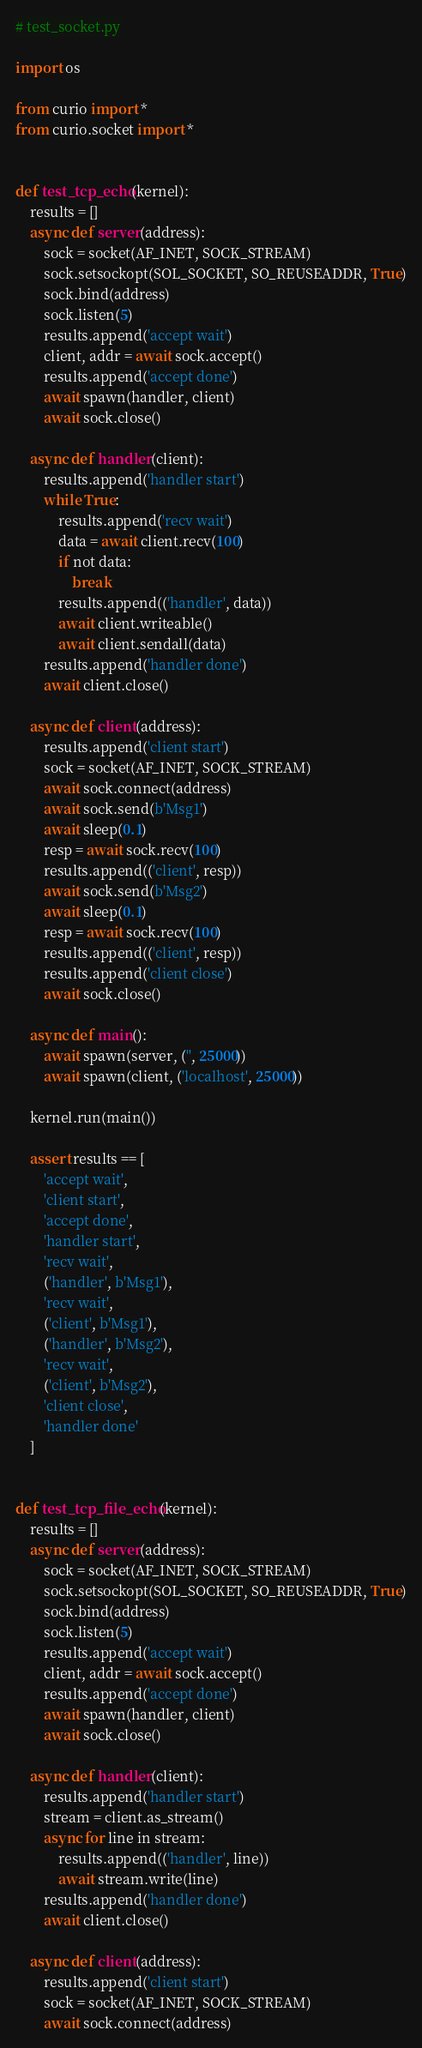<code> <loc_0><loc_0><loc_500><loc_500><_Python_># test_socket.py

import os

from curio import *
from curio.socket import *


def test_tcp_echo(kernel):
    results = []
    async def server(address):
        sock = socket(AF_INET, SOCK_STREAM)
        sock.setsockopt(SOL_SOCKET, SO_REUSEADDR, True)
        sock.bind(address)
        sock.listen(5)
        results.append('accept wait')
        client, addr = await sock.accept()
        results.append('accept done')
        await spawn(handler, client)
        await sock.close()

    async def handler(client):
        results.append('handler start')
        while True:
            results.append('recv wait')
            data = await client.recv(100)
            if not data:
                break
            results.append(('handler', data))
            await client.writeable()
            await client.sendall(data)
        results.append('handler done')
        await client.close()

    async def client(address):
        results.append('client start')
        sock = socket(AF_INET, SOCK_STREAM)
        await sock.connect(address)
        await sock.send(b'Msg1')
        await sleep(0.1)
        resp = await sock.recv(100)
        results.append(('client', resp))
        await sock.send(b'Msg2')
        await sleep(0.1)
        resp = await sock.recv(100)
        results.append(('client', resp))
        results.append('client close')
        await sock.close()

    async def main():
        await spawn(server, ('', 25000))
        await spawn(client, ('localhost', 25000))

    kernel.run(main())

    assert results == [
        'accept wait',
        'client start',
        'accept done',
        'handler start',
        'recv wait',
        ('handler', b'Msg1'),
        'recv wait',
        ('client', b'Msg1'),
        ('handler', b'Msg2'),
        'recv wait',
        ('client', b'Msg2'),
        'client close',
        'handler done'
    ]


def test_tcp_file_echo(kernel):
    results = []
    async def server(address):
        sock = socket(AF_INET, SOCK_STREAM)
        sock.setsockopt(SOL_SOCKET, SO_REUSEADDR, True)
        sock.bind(address)
        sock.listen(5)
        results.append('accept wait')
        client, addr = await sock.accept()
        results.append('accept done')
        await spawn(handler, client)
        await sock.close()

    async def handler(client):
        results.append('handler start')
        stream = client.as_stream()
        async for line in stream:
            results.append(('handler', line))
            await stream.write(line)
        results.append('handler done')
        await client.close()

    async def client(address):
        results.append('client start')
        sock = socket(AF_INET, SOCK_STREAM)
        await sock.connect(address)</code> 